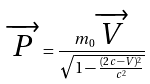Convert formula to latex. <formula><loc_0><loc_0><loc_500><loc_500>\overrightarrow { P } = \frac { m _ { 0 } { \overrightarrow { V } } } { \sqrt { 1 - \frac { ( 2 c - V ) ^ { 2 } } { c ^ { 2 } } } }</formula> 